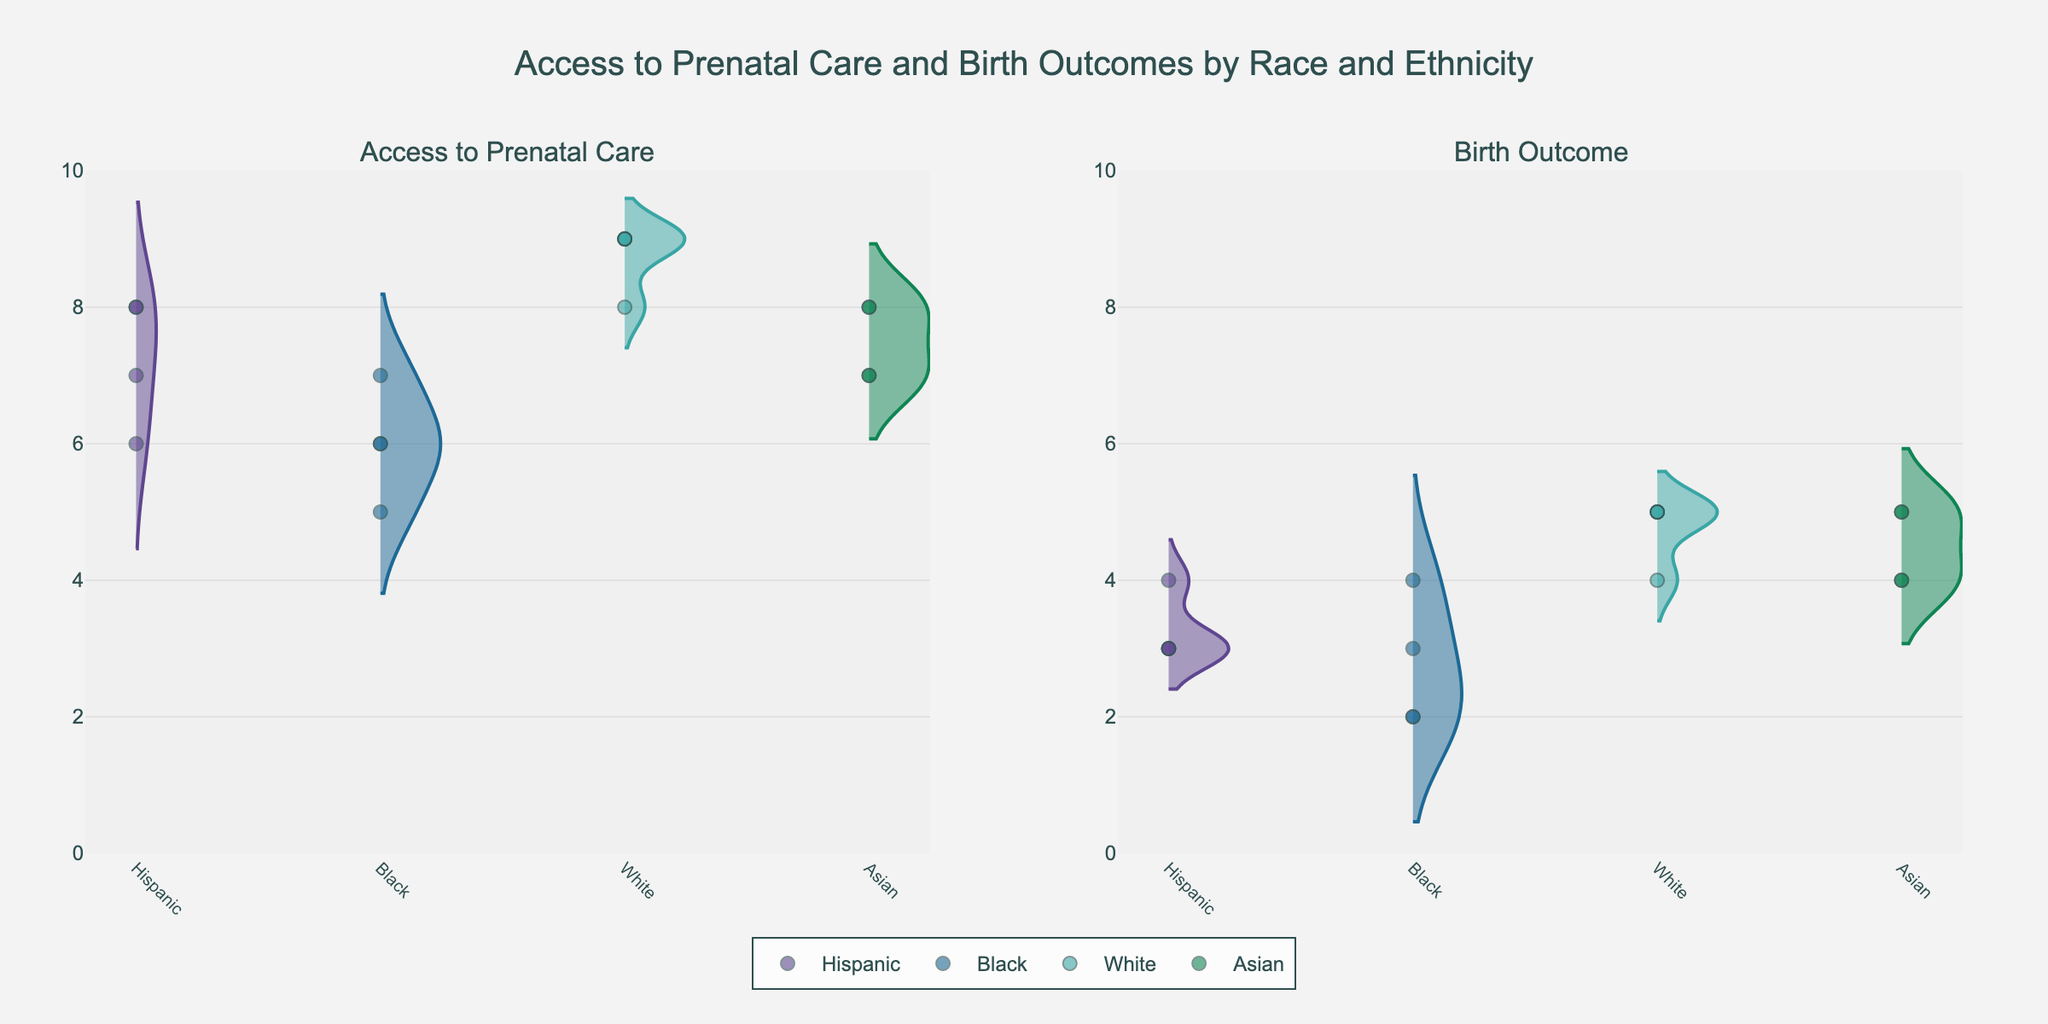What is the title of the figure? The title of the figure is located at the top center of the plot. It reads "Access to Prenatal Care and Birth Outcomes by Race and Ethnicity".
Answer: Access to Prenatal Care and Birth Outcomes by Race and Ethnicity How many subplots are in the figure? The figure contains two subplots side by side.
Answer: 2 Which race and ethnicity group has the highest median value for Access to Prenatal Care? The group with the highest median value for Access to Prenatal Care can be observed by looking at the central tendency of the violin plots. The White group shows the highest median value at 9.
Answer: White Which county has the lowest Access to Prenatal Care among the Black group? By examining the jittered points and their placement in the violin plot for the Black group, Cook County shows points at the lowest value of 5.
Answer: Cook County Compare the median Birth Outcomes for the Asian and Black groups. Which one is higher, and by how much? To compare these, look at the central part of the violin plots for Birth Outcomes. The median for Asians is higher (5) compared to Blacks (3), the difference is 2.
Answer: Asian by 2 What is the lowest Birth Outcome value recorded for the Hispanic group? By looking at the jittered points inside the violin plot for the Hispanic group in the Birth Outcome subplot, the lowest value observed is 3.
Answer: 3 How does Access to Prenatal Care for the Hispanic group in King County compare to that in Maricopa County? Checking the jittered points for the Hispanic group in Access to Prenatal Care, both King County and Suffolk County have values at 8, whereas Maricopa County shows 7.
Answer: Higher in King County What are the maximum Birth Outcomes recorded for the White group? Observing the jittered points for the White group in the Birth Outcome subplot, the maximum value recorded is 5.
Answer: 5 Is there any county where the Access to Prenatal Care for Black and Hispanic groups is equal? By comparing jittered points in the Access to Prenatal Care subplot for both Black and Hispanic groups, Maricopa County shows equal values at 6.
Answer: Yes, Maricopa County How many unique data points are there for the Asian group in the Birth Outcome subplot? Each jittered point represents a unique data point. Counting these points for the Asian group in Birth Outcome, there are 4 such points.
Answer: 4 